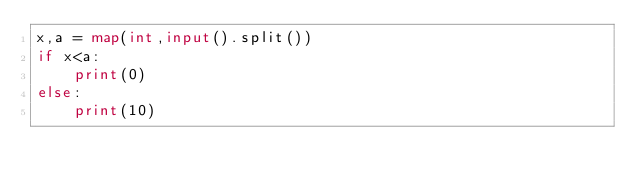<code> <loc_0><loc_0><loc_500><loc_500><_Python_>x,a = map(int,input().split())
if x<a:
    print(0)
else:
    print(10)</code> 